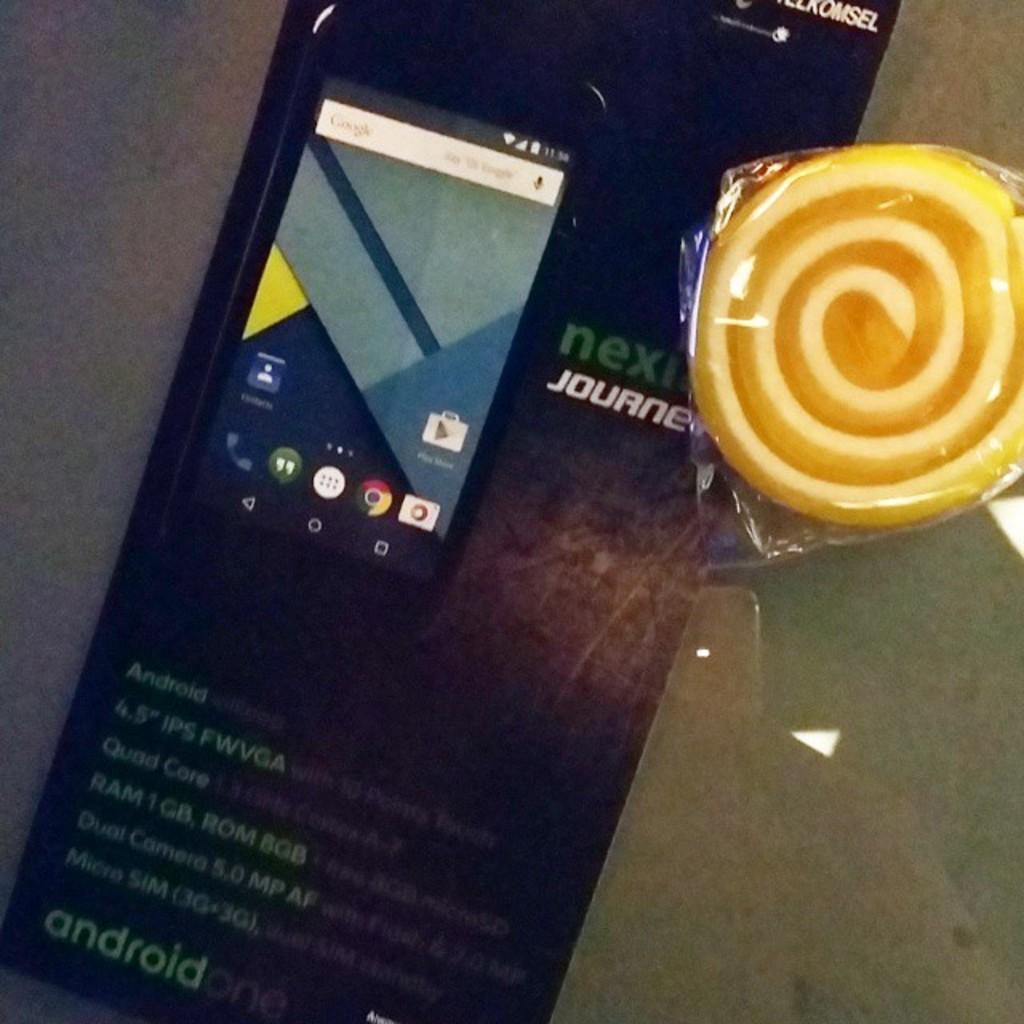Provide a one-sentence caption for the provided image. The phone shown is an android one phone. 